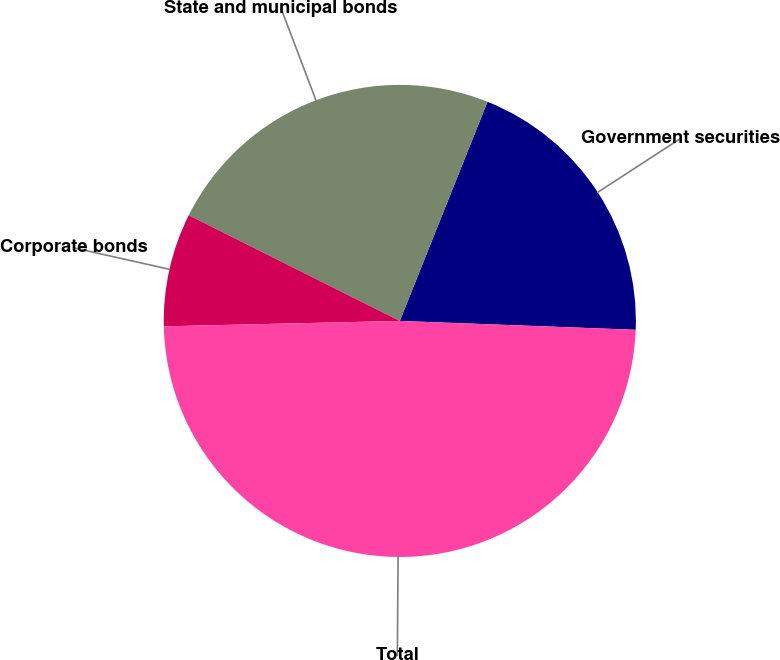Convert chart to OTSL. <chart><loc_0><loc_0><loc_500><loc_500><pie_chart><fcel>Government securities<fcel>State and municipal bonds<fcel>Corporate bonds<fcel>Total<nl><fcel>19.54%<fcel>23.67%<fcel>7.75%<fcel>49.03%<nl></chart> 